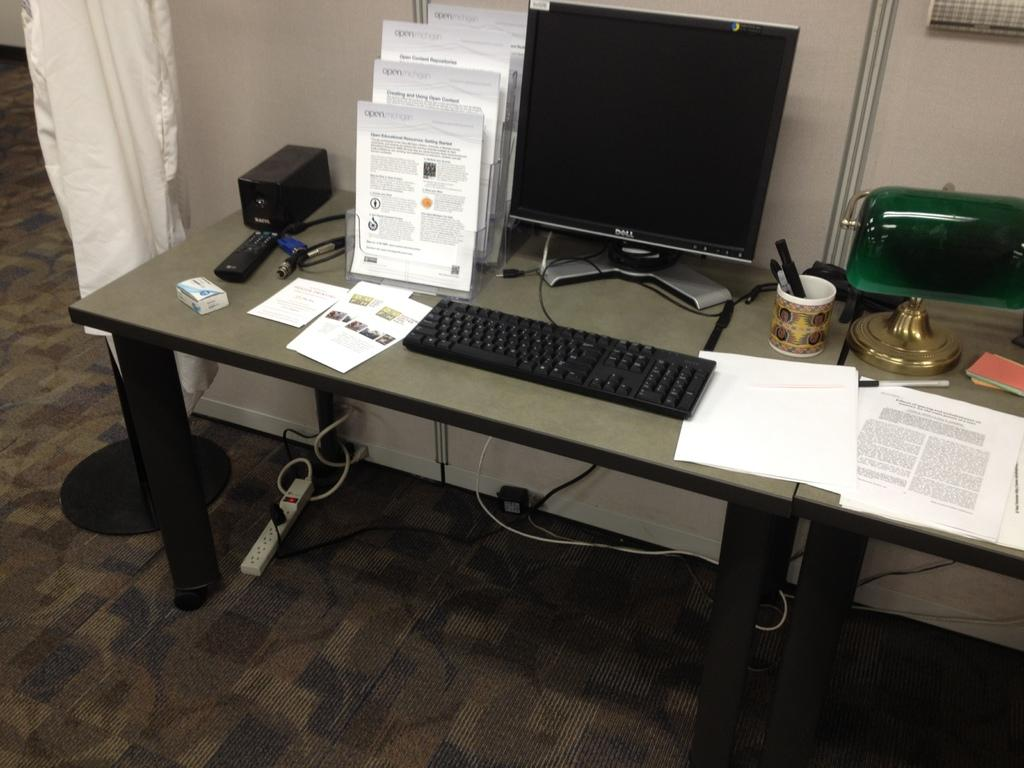What items can be seen on the table in the image? There are books, a computer, a keyboard, and papers on the table in the image. What is the purpose of the keyboard? The keyboard is likely used for typing on the computer. What can be found on the floor in the image? There are cables and a plug box on the floor. What is the function of the plug box? The plug box is used for connecting electrical devices, such as the computer and keyboard, to a power source. What is beside the table in the image? There is a curtain beside the table. What type of harmony can be heard coming from the cave in the image? There is no cave present in the image, so it is not possible to determine what, if any, harmony might be heard. 